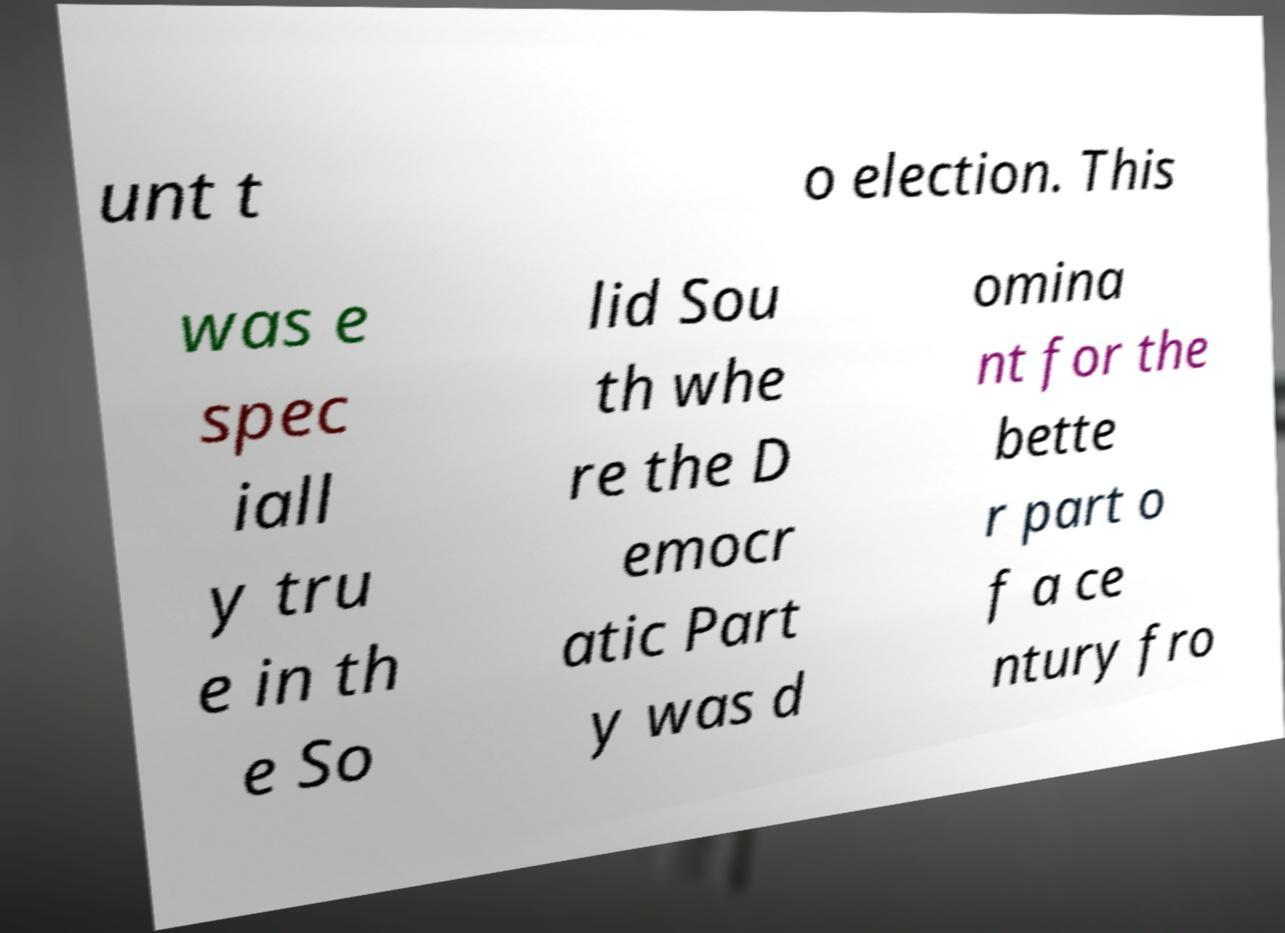Can you accurately transcribe the text from the provided image for me? unt t o election. This was e spec iall y tru e in th e So lid Sou th whe re the D emocr atic Part y was d omina nt for the bette r part o f a ce ntury fro 